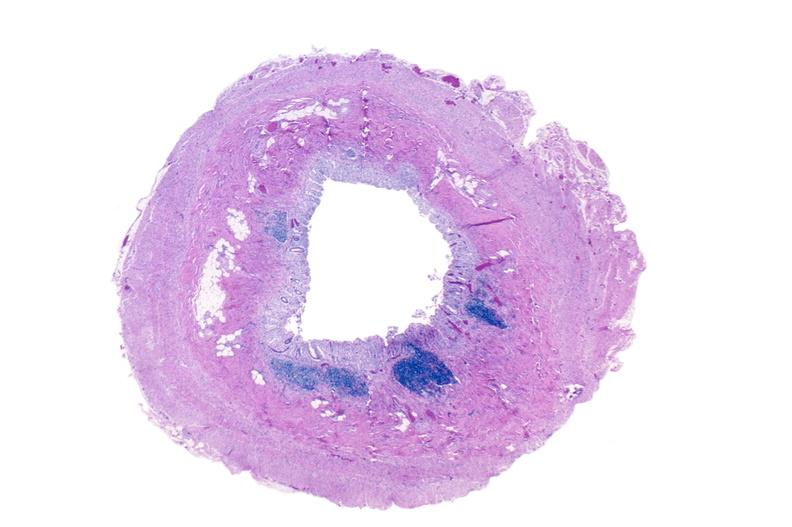s atrophy secondary to pituitectomy present?
Answer the question using a single word or phrase. No 